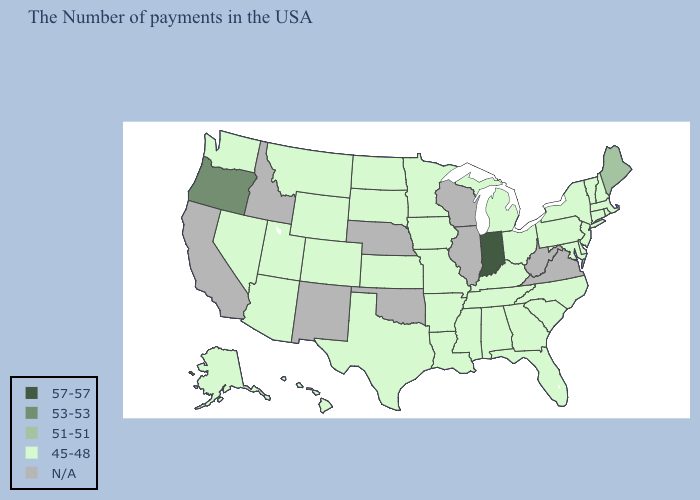What is the value of Rhode Island?
Concise answer only. 45-48. What is the value of South Dakota?
Write a very short answer. 45-48. Which states have the lowest value in the Northeast?
Quick response, please. Massachusetts, Rhode Island, New Hampshire, Vermont, Connecticut, New York, New Jersey, Pennsylvania. What is the lowest value in the West?
Quick response, please. 45-48. What is the lowest value in the West?
Answer briefly. 45-48. Which states have the highest value in the USA?
Concise answer only. Indiana. Does Maine have the lowest value in the USA?
Quick response, please. No. What is the value of New Jersey?
Give a very brief answer. 45-48. What is the highest value in the West ?
Keep it brief. 53-53. What is the lowest value in the South?
Keep it brief. 45-48. What is the value of Alabama?
Write a very short answer. 45-48. Name the states that have a value in the range 53-53?
Answer briefly. Oregon. 